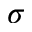Convert formula to latex. <formula><loc_0><loc_0><loc_500><loc_500>\sigma</formula> 